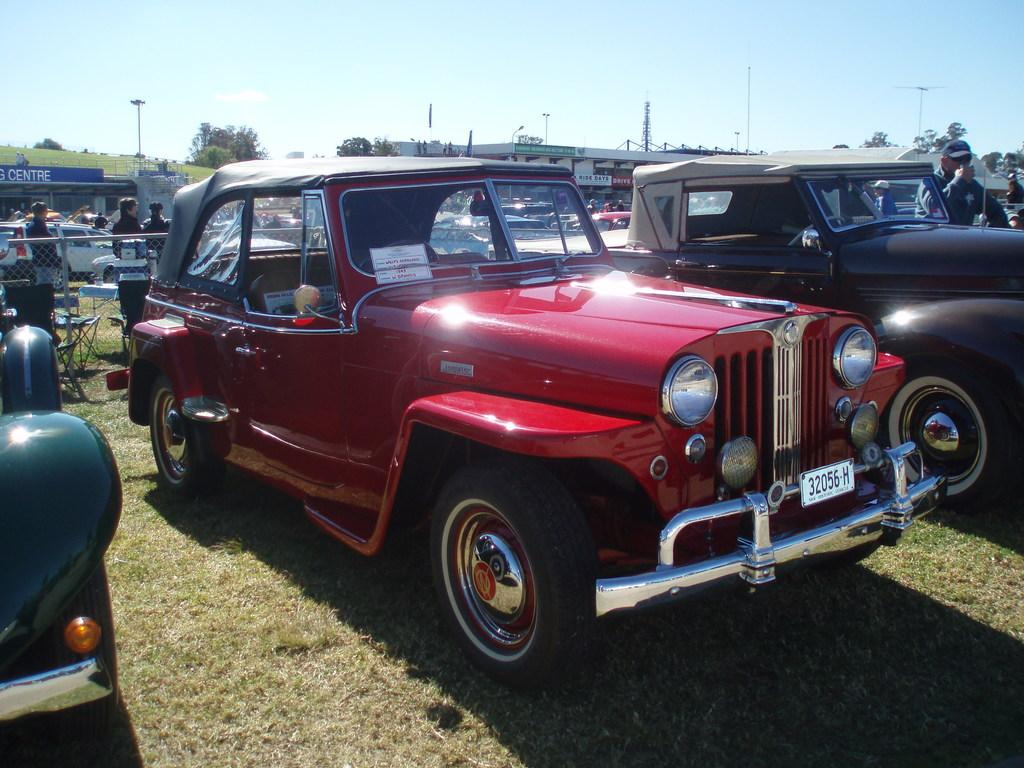What types of objects are on the ground in the image? There are motor vehicles and persons standing on the ground in the image. What structures can be seen in the image? There are buildings, towers, and a fence in the image. What additional features are present in the image? There are name boards and trees in the image. What can be seen in the sky in the image? The sky is visible in the image. Can you tell me how many umbrellas are being used by the animals in the image? There are no umbrellas or animals present in the image. What type of cannon is located near the towers in the image? There is no cannon present in the image; only motor vehicles, persons, buildings, towers, a fence, name boards, trees, and the sky are visible. 